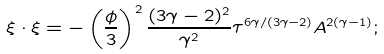<formula> <loc_0><loc_0><loc_500><loc_500>\xi \cdot \xi = - \left ( \frac { \phi } { 3 } \right ) ^ { 2 } \frac { ( 3 \gamma - 2 ) ^ { 2 } } { \gamma ^ { 2 } } \tau ^ { 6 \gamma / ( 3 \gamma - 2 ) } A ^ { 2 ( \gamma - 1 ) } ;</formula> 